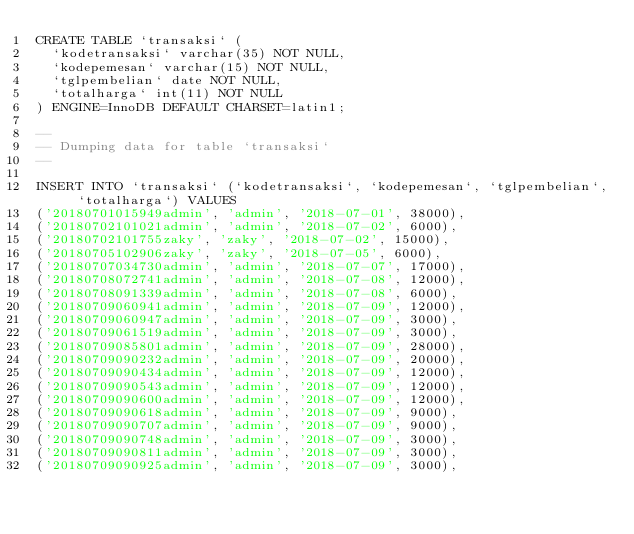Convert code to text. <code><loc_0><loc_0><loc_500><loc_500><_SQL_>CREATE TABLE `transaksi` (
  `kodetransaksi` varchar(35) NOT NULL,
  `kodepemesan` varchar(15) NOT NULL,
  `tglpembelian` date NOT NULL,
  `totalharga` int(11) NOT NULL
) ENGINE=InnoDB DEFAULT CHARSET=latin1;

--
-- Dumping data for table `transaksi`
--

INSERT INTO `transaksi` (`kodetransaksi`, `kodepemesan`, `tglpembelian`, `totalharga`) VALUES
('20180701015949admin', 'admin', '2018-07-01', 38000),
('20180702101021admin', 'admin', '2018-07-02', 6000),
('20180702101755zaky', 'zaky', '2018-07-02', 15000),
('20180705102906zaky', 'zaky', '2018-07-05', 6000),
('20180707034730admin', 'admin', '2018-07-07', 17000),
('20180708072741admin', 'admin', '2018-07-08', 12000),
('20180708091339admin', 'admin', '2018-07-08', 6000),
('20180709060941admin', 'admin', '2018-07-09', 12000),
('20180709060947admin', 'admin', '2018-07-09', 3000),
('20180709061519admin', 'admin', '2018-07-09', 3000),
('20180709085801admin', 'admin', '2018-07-09', 28000),
('20180709090232admin', 'admin', '2018-07-09', 20000),
('20180709090434admin', 'admin', '2018-07-09', 12000),
('20180709090543admin', 'admin', '2018-07-09', 12000),
('20180709090600admin', 'admin', '2018-07-09', 12000),
('20180709090618admin', 'admin', '2018-07-09', 9000),
('20180709090707admin', 'admin', '2018-07-09', 9000),
('20180709090748admin', 'admin', '2018-07-09', 3000),
('20180709090811admin', 'admin', '2018-07-09', 3000),
('20180709090925admin', 'admin', '2018-07-09', 3000),</code> 